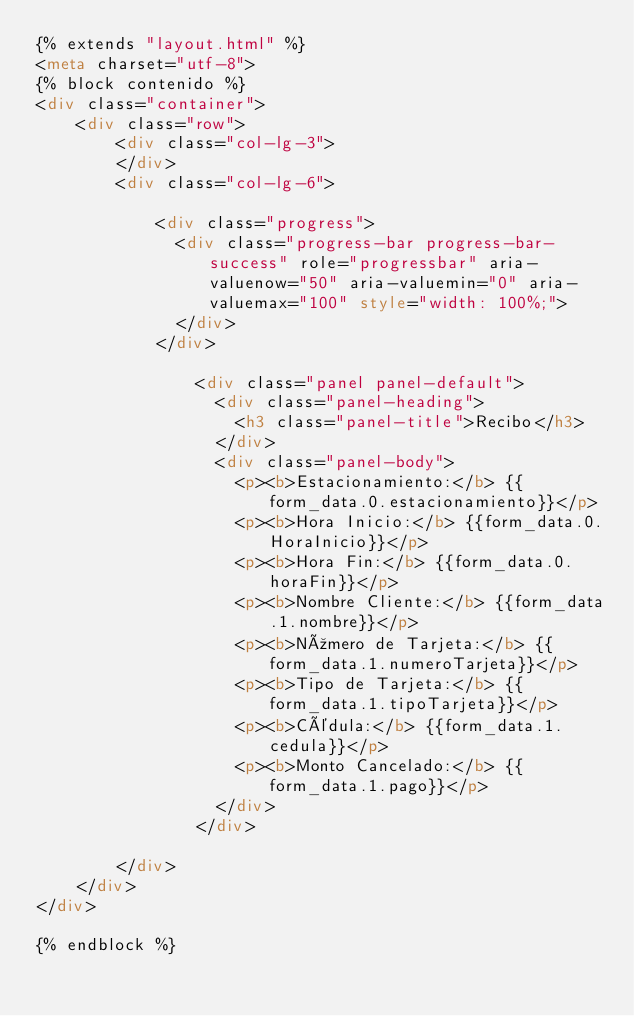Convert code to text. <code><loc_0><loc_0><loc_500><loc_500><_HTML_>{% extends "layout.html" %}
<meta charset="utf-8">
{% block contenido %}
<div class="container">
	<div class="row">
		<div class="col-lg-3">
		</div>
		<div class="col-lg-6">
		
			<div class="progress">
			  <div class="progress-bar progress-bar-success" role="progressbar" aria-valuenow="50" aria-valuemin="0" aria-valuemax="100" style="width: 100%;">
			  </div>
			</div>
			
				<div class="panel panel-default">
				  <div class="panel-heading">
					<h3 class="panel-title">Recibo</h3>
				  </div>
				  <div class="panel-body">
					<p><b>Estacionamiento:</b> {{form_data.0.estacionamiento}}</p>
					<p><b>Hora Inicio:</b> {{form_data.0.HoraInicio}}</p>
					<p><b>Hora Fin:</b> {{form_data.0.horaFin}}</p>
					<p><b>Nombre Cliente:</b> {{form_data.1.nombre}}</p>
					<p><b>Número de Tarjeta:</b> {{form_data.1.numeroTarjeta}}</p>
					<p><b>Tipo de Tarjeta:</b> {{form_data.1.tipoTarjeta}}</p>
					<p><b>Cédula:</b> {{form_data.1.cedula}}</p>
					<p><b>Monto Cancelado:</b> {{form_data.1.pago}}</p>
				  </div>
				</div>

		</div>
	</div>
</div>
	
{% endblock %}</code> 